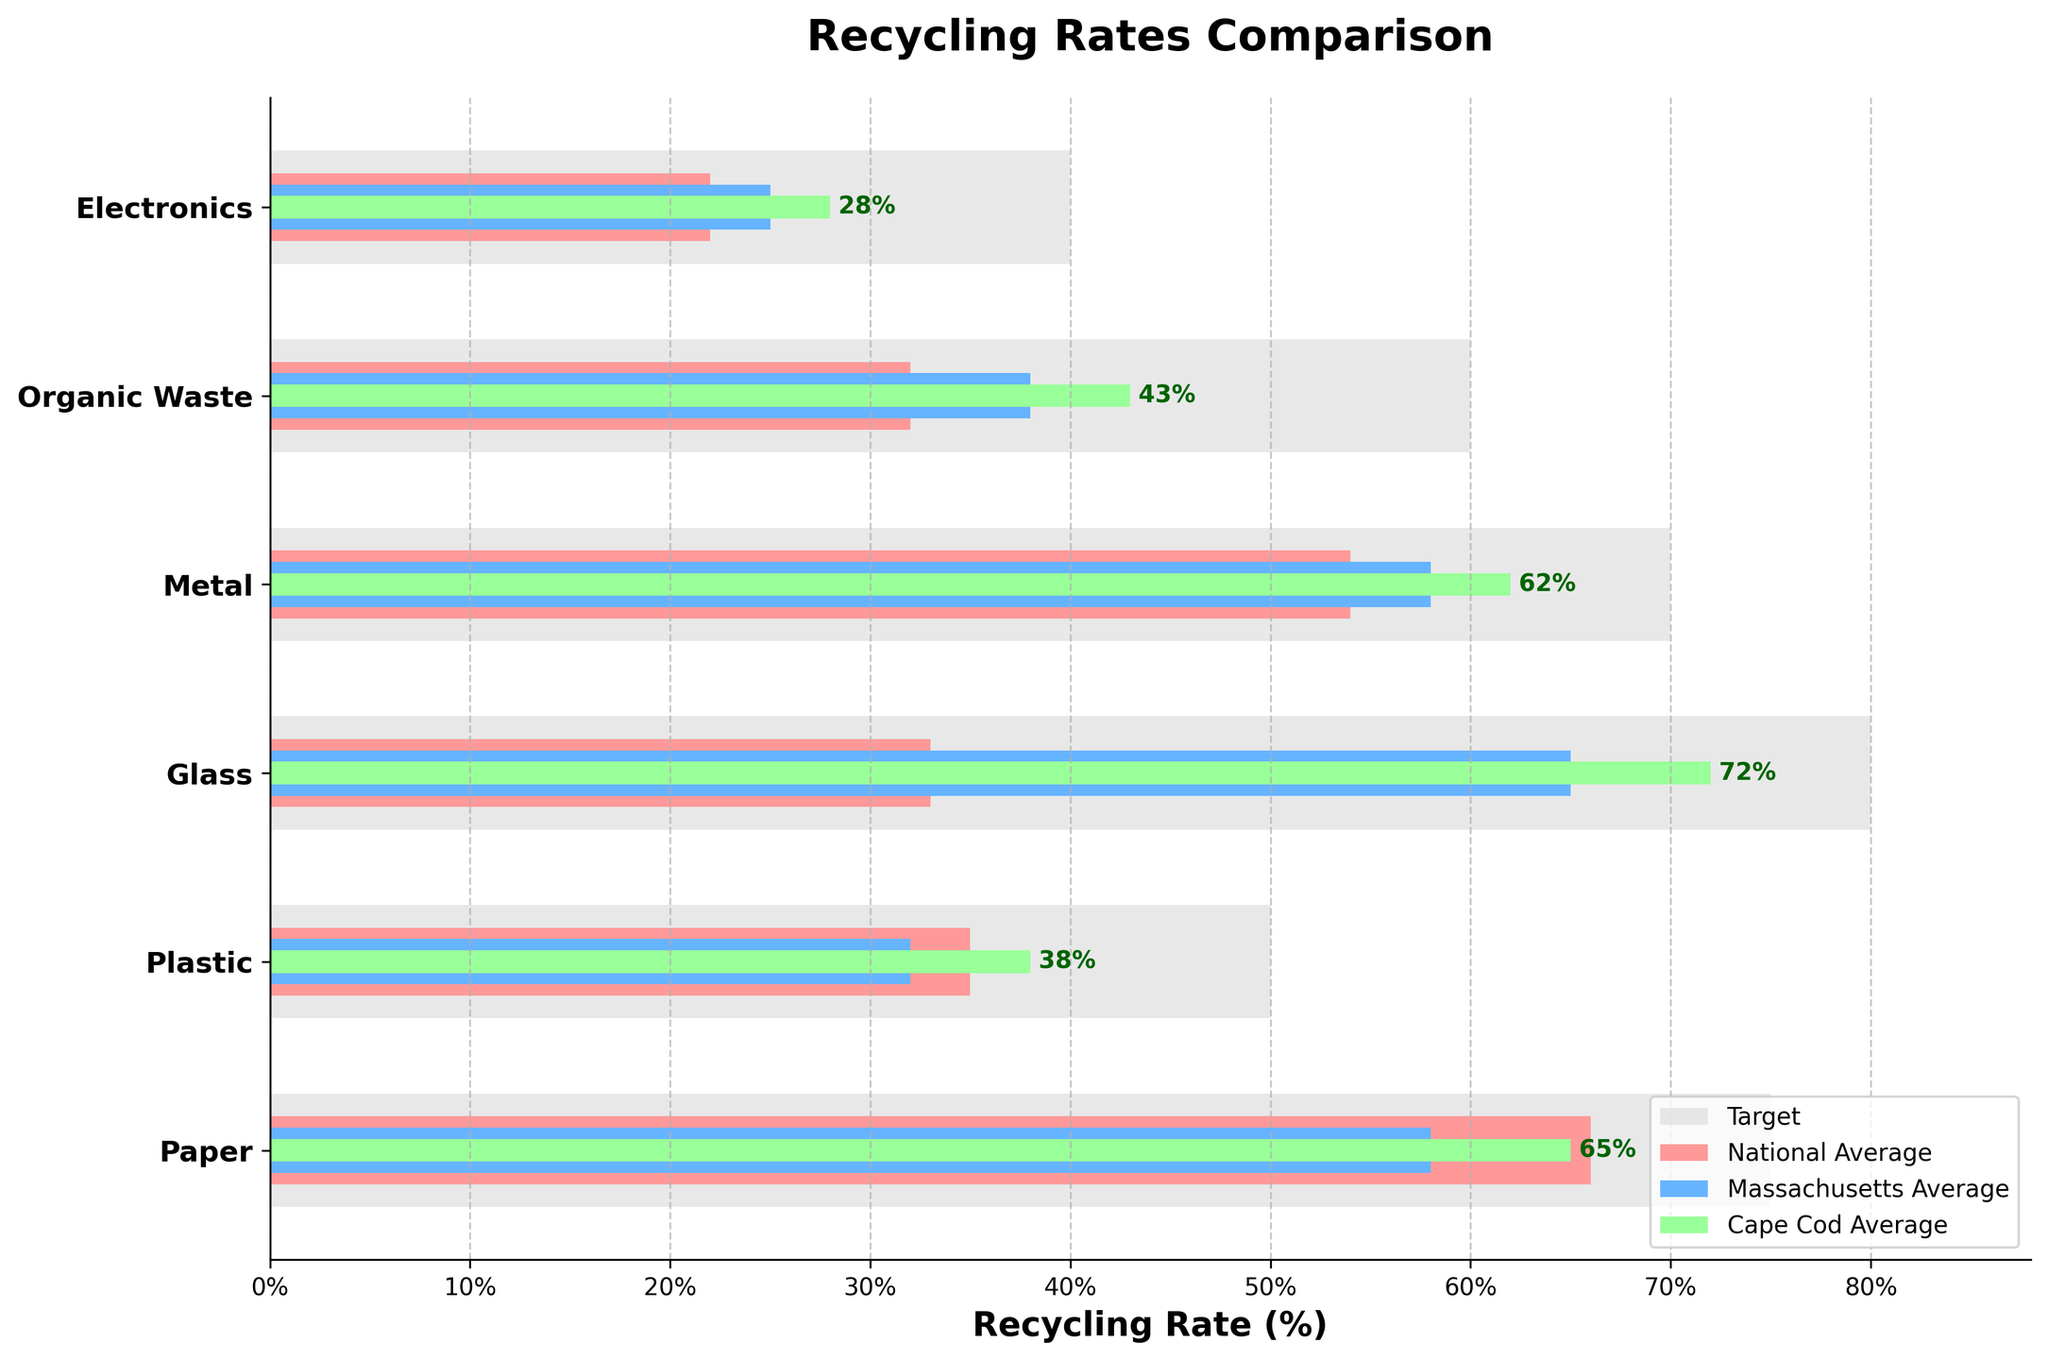What's the title of the figure? The title is displayed at the top of the figure and is typically in a larger font size than other text elements.
Answer: Recycling Rates Comparison What materials have a higher recycling rate in Cape Cod than the national average? Compare the heights of the bars for Cape Cod and the national average for each material. Materials where Cape Cod's bars are longer indicate higher recycling rates.
Answer: Paper, Plastic, Glass, Metal, Organic Waste, Electronics Which material has the lowest recycling rate in Cape Cod? Look at the left end of the Cape Cod bars and find the one that extends the least to the right.
Answer: Electronics How does the recycling rate of glass in Cape Cod compare to the Massachusetts and national averages? Compare the lengths of the bars for glass. The Cape Cod bar for glass is longer than the Massachusetts and national bars.
Answer: Higher Is Cape Cod meeting the recycling targets for any materials? Check if any Cape Cod bars reach or exceed the gray target bars for each material. None do.
Answer: No What is the difference between the Cape Cod recycling rate of organic waste and its target rate? Subtract the Cape Cod recycling rate for organic waste from the target rate for organic waste (60 - 43).
Answer: 17% Which material has the largest gap between Cape Cod's recycling rate and the target rate? For each material, subtract Cape Cod's rate from the target rate, and identify the largest difference. Electronics has the largest difference (40 - 28 = 12).
Answer: Electronics By how much does Cape Cod's recycling rate for paper exceed the Massachusetts average? Subtract the Massachusetts average for paper from Cape Cod's recycling rate for paper (65 - 58).
Answer: 7% Which material shows the greatest difference between the national and Massachusetts recycling averages? Calculate the absolute differences between the national and Massachusetts averages for each material, and find the material with the greatest difference. Glass has the largest difference (65 - 33 = 32).
Answer: Glass 